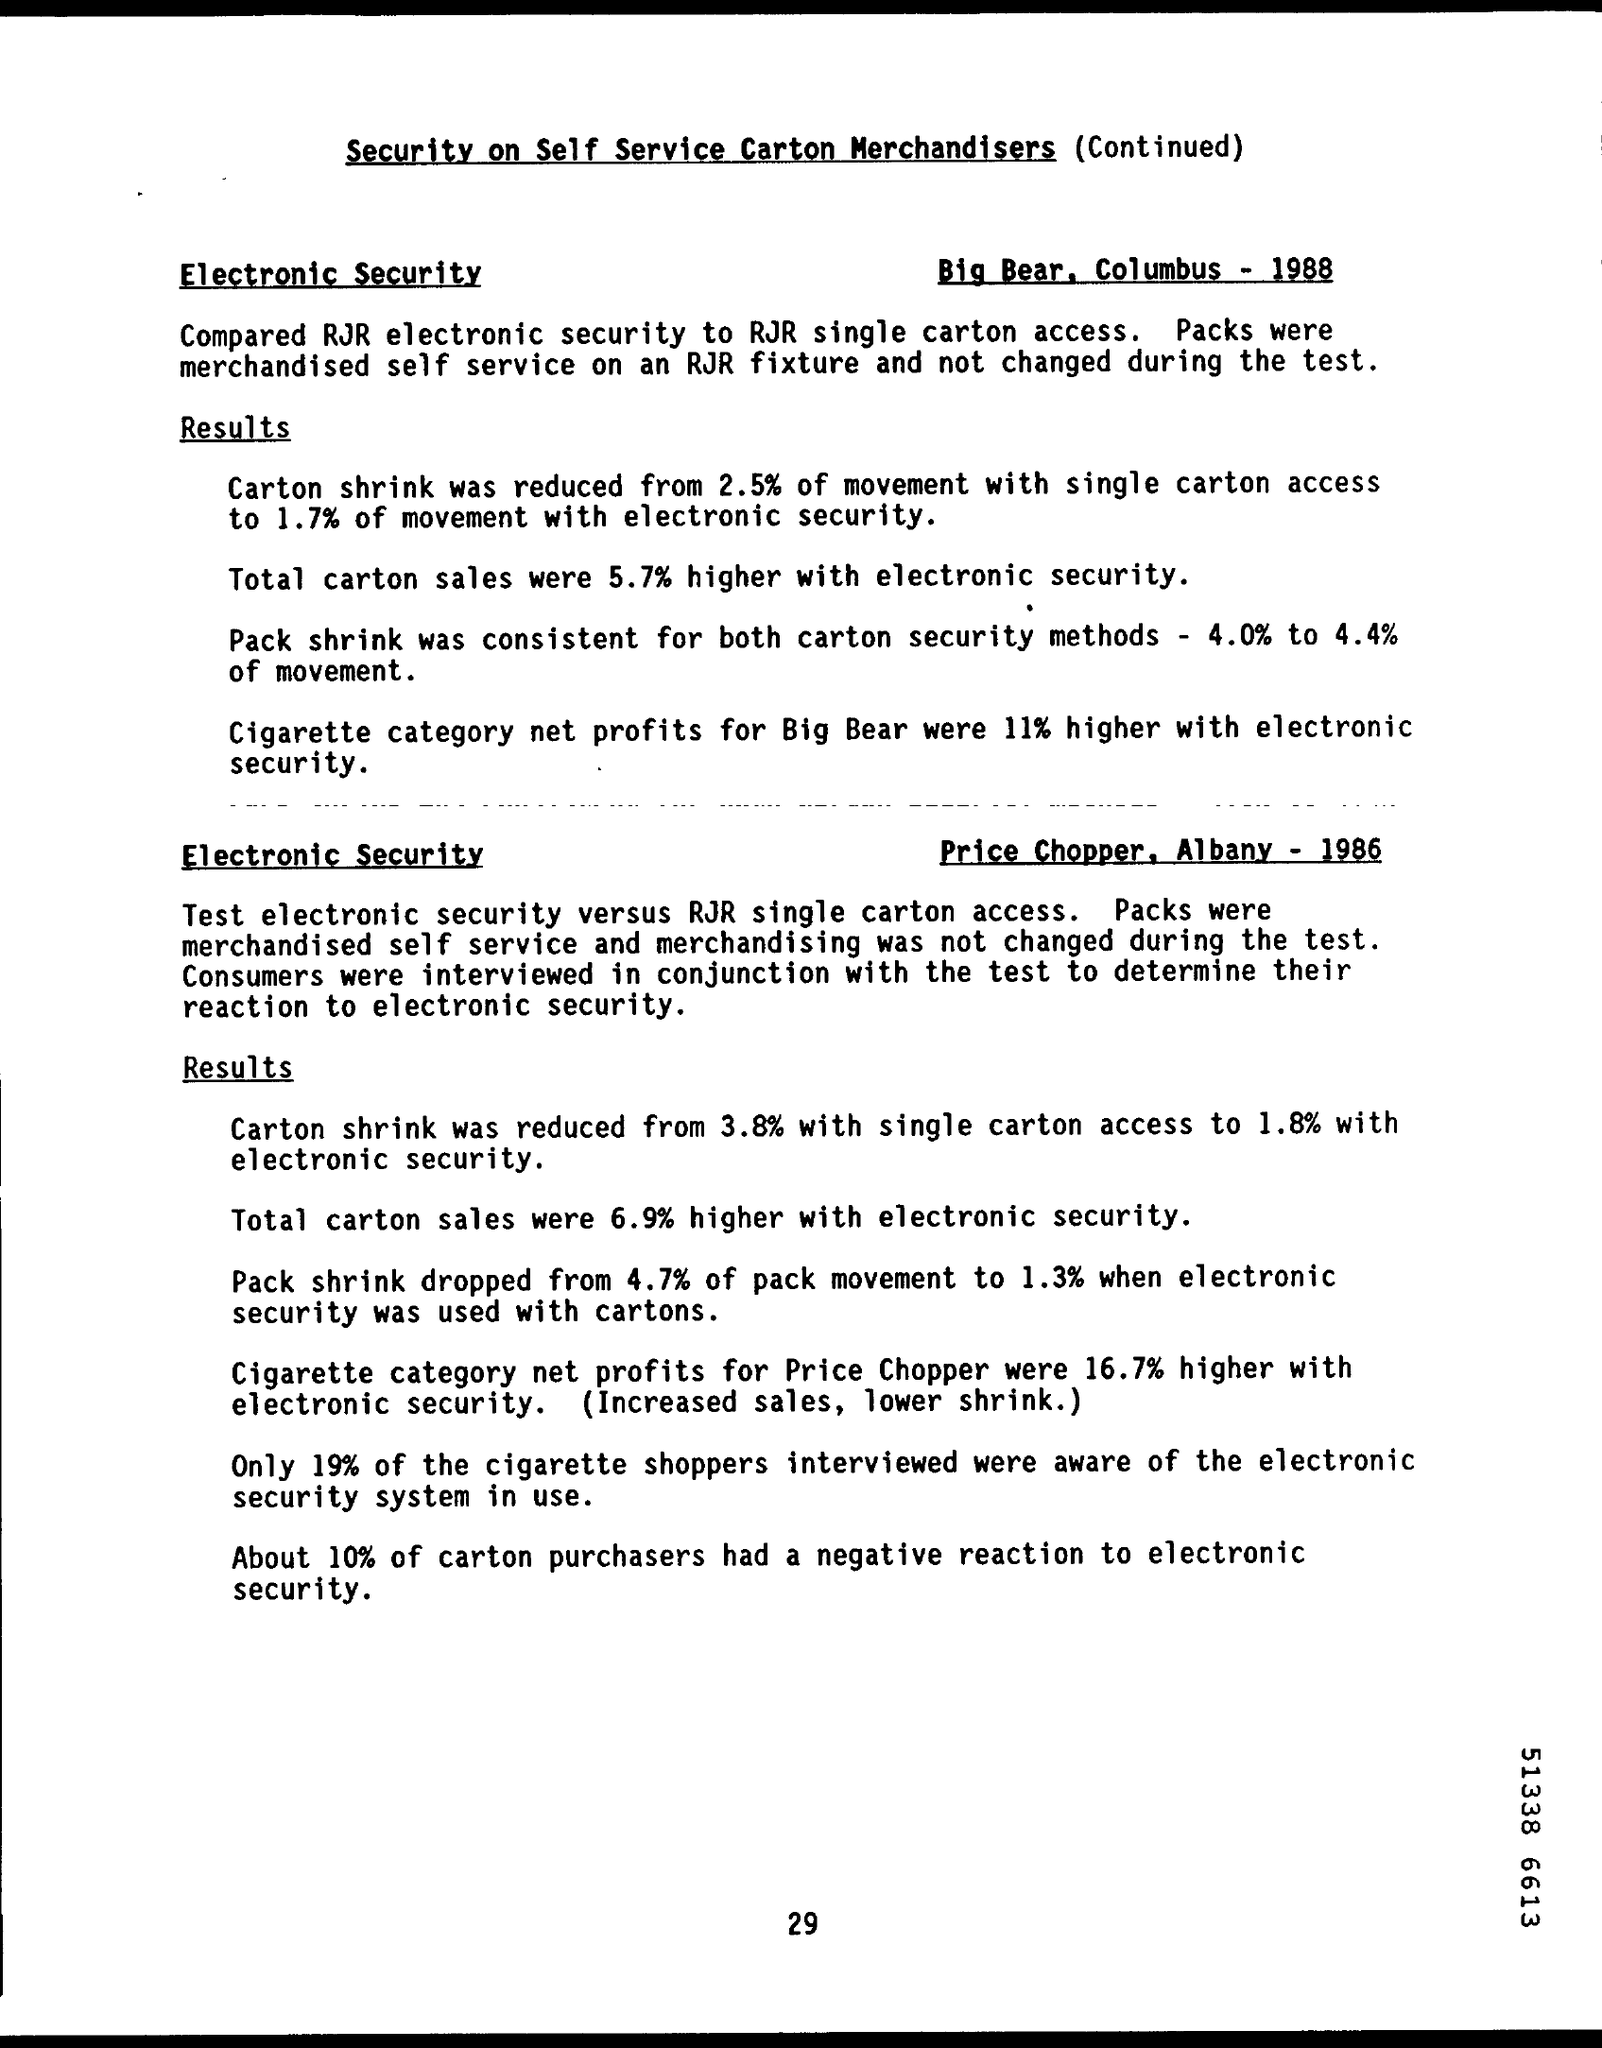How high did total carton sales go with electronic security in Big Bear?
Provide a succinct answer. 5.7% higher. In Albany, what percentage of carton purchasers had a negative reaction to electronic security?
Ensure brevity in your answer.  10%. What is the document title?
Your answer should be very brief. Security on self service carton merchandisers (continued). 